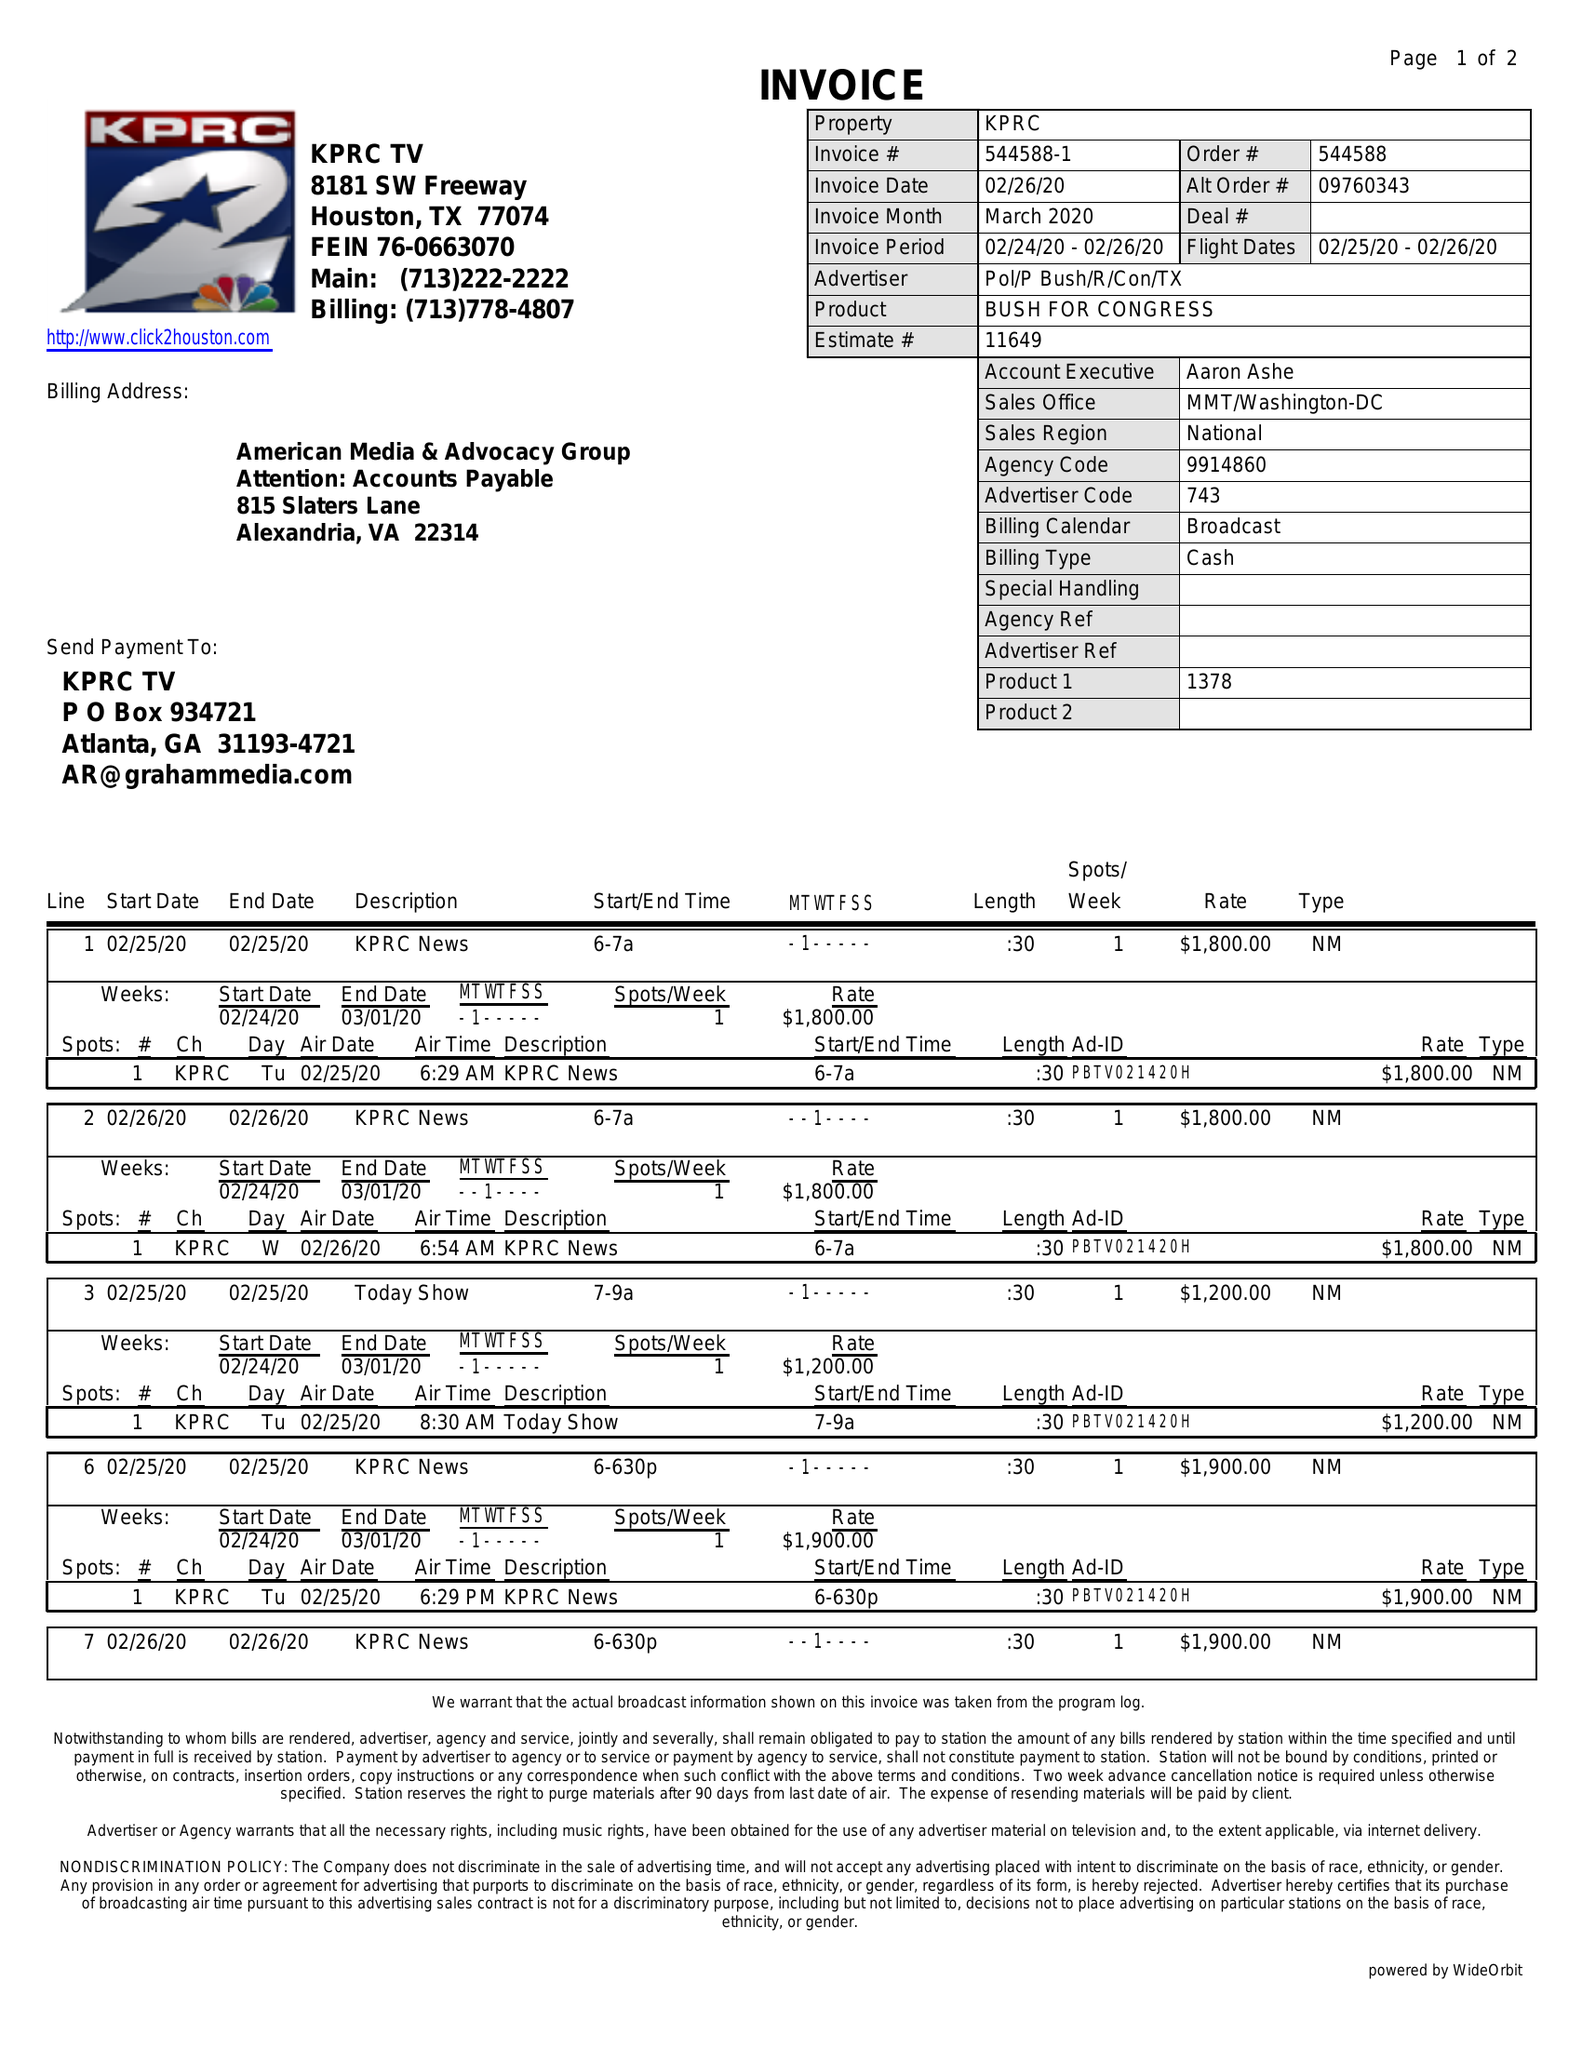What is the value for the flight_from?
Answer the question using a single word or phrase. 02/25/20 